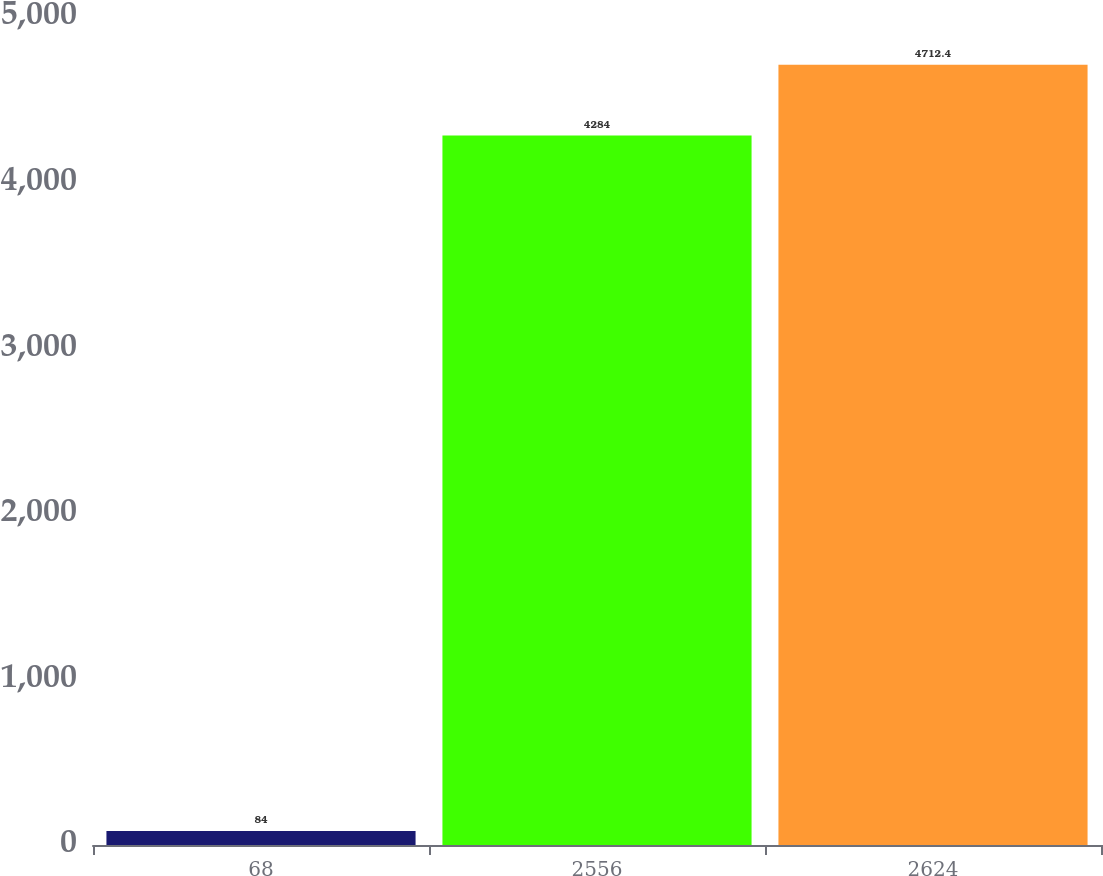<chart> <loc_0><loc_0><loc_500><loc_500><bar_chart><fcel>68<fcel>2556<fcel>2624<nl><fcel>84<fcel>4284<fcel>4712.4<nl></chart> 